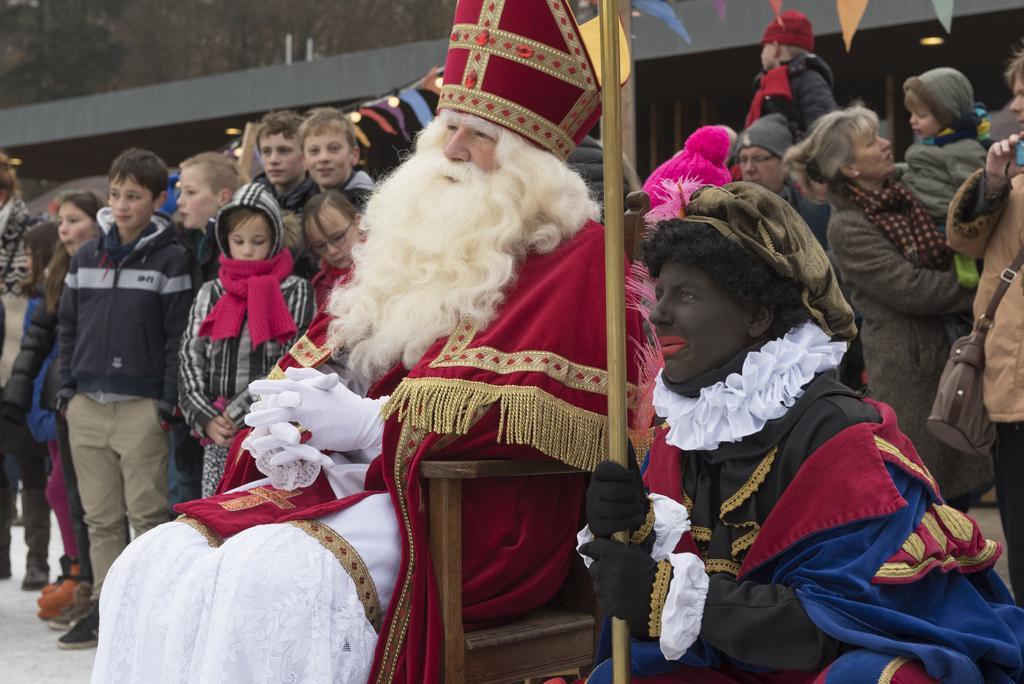Please provide a concise description of this image. In this image we can see a man wearing the costume sitting on a chair and a person sitting beside him holding a pole. On the backside we can see a group of people standing, the flags, a building and a ceiling light to a roof. 